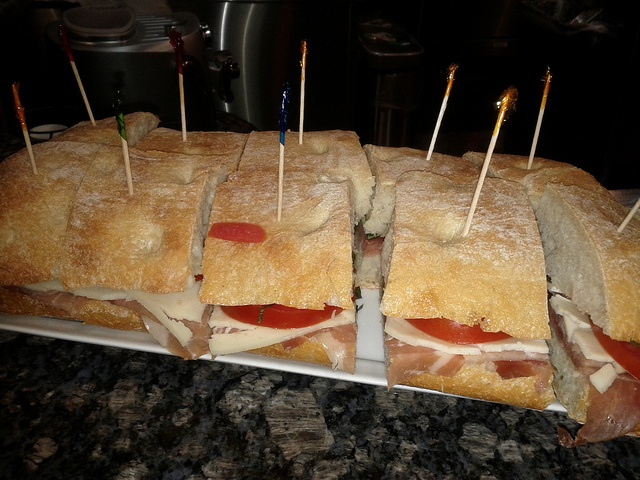Describe the objects in this image and their specific colors. I can see dining table in black and gray tones, sandwich in black, tan, and gray tones, sandwich in black, tan, and gray tones, sandwich in black, tan, gray, olive, and maroon tones, and sandwich in black, tan, gray, brown, and maroon tones in this image. 